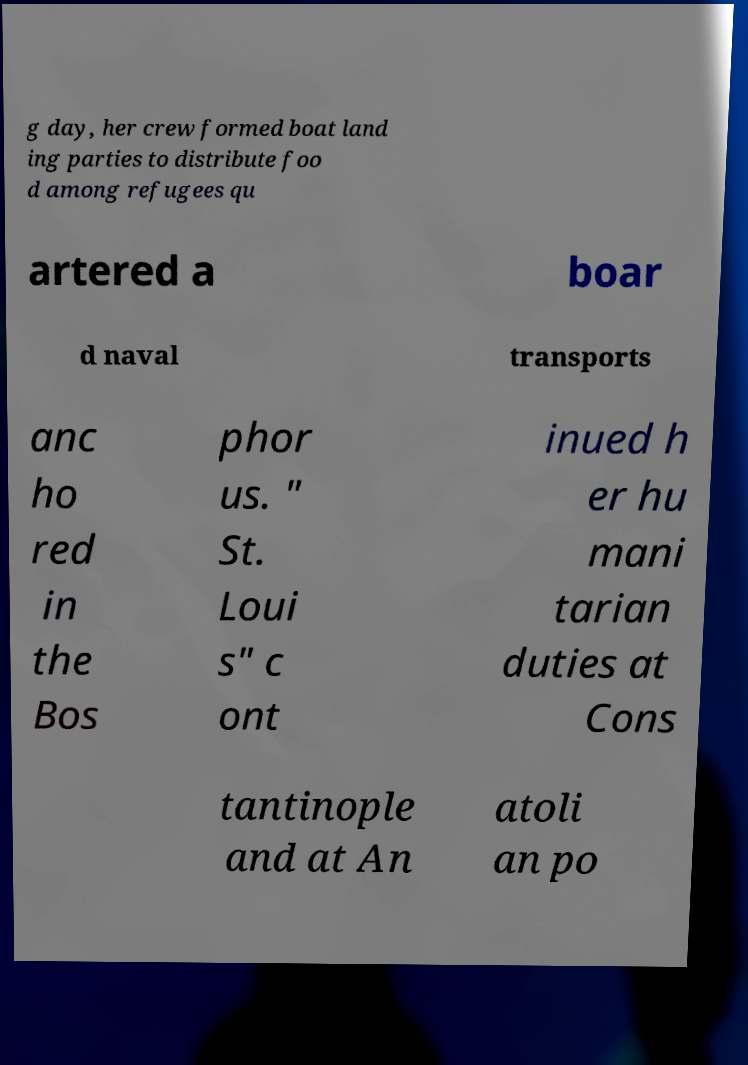Please identify and transcribe the text found in this image. g day, her crew formed boat land ing parties to distribute foo d among refugees qu artered a boar d naval transports anc ho red in the Bos phor us. " St. Loui s" c ont inued h er hu mani tarian duties at Cons tantinople and at An atoli an po 